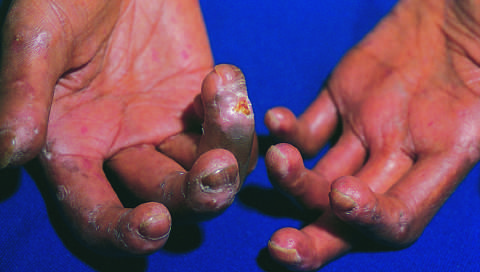what has virtually immobilized the fingers, creating a clawlike flexion deformity?
Answer the question using a single word or phrase. Extensive subcutaneous fibrosis 